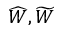Convert formula to latex. <formula><loc_0><loc_0><loc_500><loc_500>\widehat { W } , \widetilde { W }</formula> 